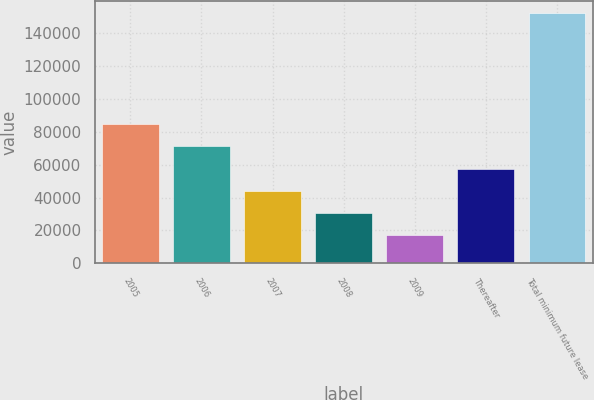Convert chart. <chart><loc_0><loc_0><loc_500><loc_500><bar_chart><fcel>2005<fcel>2006<fcel>2007<fcel>2008<fcel>2009<fcel>Thereafter<fcel>Total minimum future lease<nl><fcel>84503<fcel>71038<fcel>44108<fcel>30643<fcel>17178<fcel>57573<fcel>151828<nl></chart> 